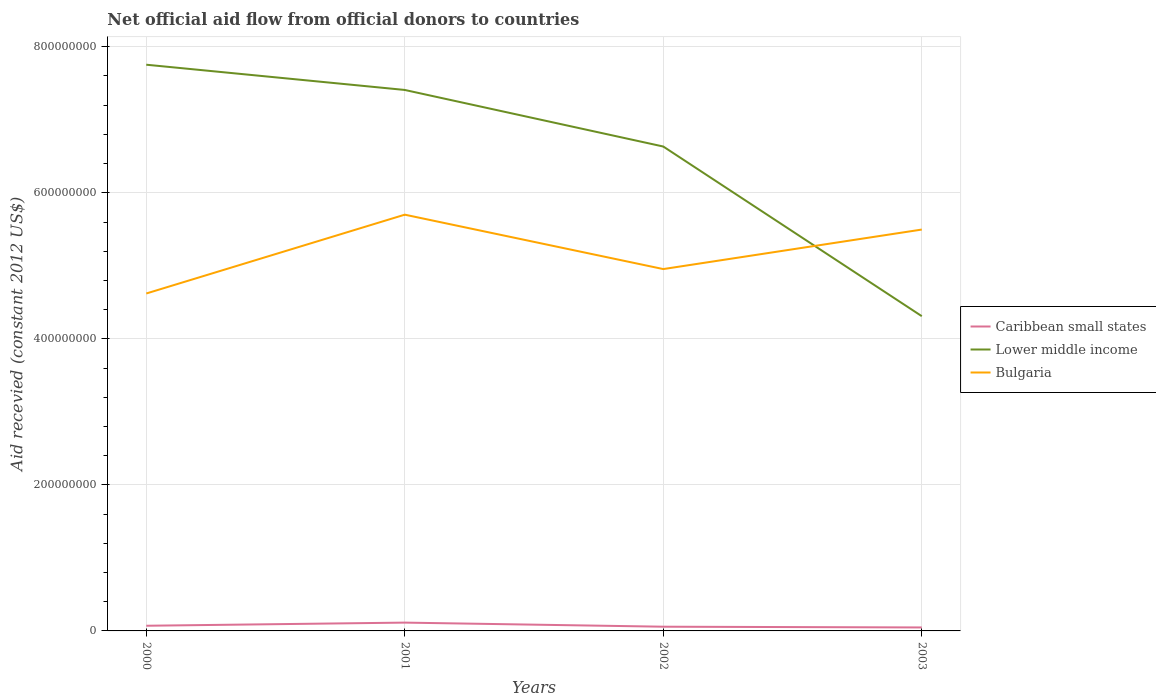How many different coloured lines are there?
Ensure brevity in your answer.  3. Does the line corresponding to Lower middle income intersect with the line corresponding to Bulgaria?
Your answer should be very brief. Yes. Across all years, what is the maximum total aid received in Caribbean small states?
Provide a succinct answer. 4.76e+06. What is the total total aid received in Lower middle income in the graph?
Your response must be concise. 3.44e+08. What is the difference between the highest and the second highest total aid received in Caribbean small states?
Keep it short and to the point. 6.62e+06. What is the difference between the highest and the lowest total aid received in Lower middle income?
Make the answer very short. 3. How many lines are there?
Keep it short and to the point. 3. Are the values on the major ticks of Y-axis written in scientific E-notation?
Give a very brief answer. No. Does the graph contain any zero values?
Provide a succinct answer. No. Does the graph contain grids?
Offer a terse response. Yes. Where does the legend appear in the graph?
Offer a terse response. Center right. What is the title of the graph?
Provide a short and direct response. Net official aid flow from official donors to countries. What is the label or title of the X-axis?
Offer a terse response. Years. What is the label or title of the Y-axis?
Ensure brevity in your answer.  Aid recevied (constant 2012 US$). What is the Aid recevied (constant 2012 US$) in Caribbean small states in 2000?
Make the answer very short. 7.08e+06. What is the Aid recevied (constant 2012 US$) in Lower middle income in 2000?
Make the answer very short. 7.75e+08. What is the Aid recevied (constant 2012 US$) in Bulgaria in 2000?
Keep it short and to the point. 4.62e+08. What is the Aid recevied (constant 2012 US$) in Caribbean small states in 2001?
Offer a very short reply. 1.14e+07. What is the Aid recevied (constant 2012 US$) in Lower middle income in 2001?
Your answer should be compact. 7.41e+08. What is the Aid recevied (constant 2012 US$) of Bulgaria in 2001?
Offer a terse response. 5.70e+08. What is the Aid recevied (constant 2012 US$) in Caribbean small states in 2002?
Make the answer very short. 5.78e+06. What is the Aid recevied (constant 2012 US$) in Lower middle income in 2002?
Your answer should be compact. 6.63e+08. What is the Aid recevied (constant 2012 US$) of Bulgaria in 2002?
Offer a very short reply. 4.96e+08. What is the Aid recevied (constant 2012 US$) in Caribbean small states in 2003?
Provide a short and direct response. 4.76e+06. What is the Aid recevied (constant 2012 US$) in Lower middle income in 2003?
Your answer should be very brief. 4.31e+08. What is the Aid recevied (constant 2012 US$) in Bulgaria in 2003?
Your answer should be compact. 5.50e+08. Across all years, what is the maximum Aid recevied (constant 2012 US$) in Caribbean small states?
Provide a short and direct response. 1.14e+07. Across all years, what is the maximum Aid recevied (constant 2012 US$) in Lower middle income?
Provide a succinct answer. 7.75e+08. Across all years, what is the maximum Aid recevied (constant 2012 US$) in Bulgaria?
Provide a succinct answer. 5.70e+08. Across all years, what is the minimum Aid recevied (constant 2012 US$) in Caribbean small states?
Keep it short and to the point. 4.76e+06. Across all years, what is the minimum Aid recevied (constant 2012 US$) of Lower middle income?
Offer a terse response. 4.31e+08. Across all years, what is the minimum Aid recevied (constant 2012 US$) of Bulgaria?
Offer a very short reply. 4.62e+08. What is the total Aid recevied (constant 2012 US$) in Caribbean small states in the graph?
Offer a terse response. 2.90e+07. What is the total Aid recevied (constant 2012 US$) in Lower middle income in the graph?
Give a very brief answer. 2.61e+09. What is the total Aid recevied (constant 2012 US$) of Bulgaria in the graph?
Your answer should be compact. 2.08e+09. What is the difference between the Aid recevied (constant 2012 US$) of Caribbean small states in 2000 and that in 2001?
Ensure brevity in your answer.  -4.30e+06. What is the difference between the Aid recevied (constant 2012 US$) in Lower middle income in 2000 and that in 2001?
Provide a short and direct response. 3.46e+07. What is the difference between the Aid recevied (constant 2012 US$) of Bulgaria in 2000 and that in 2001?
Keep it short and to the point. -1.08e+08. What is the difference between the Aid recevied (constant 2012 US$) in Caribbean small states in 2000 and that in 2002?
Offer a very short reply. 1.30e+06. What is the difference between the Aid recevied (constant 2012 US$) in Lower middle income in 2000 and that in 2002?
Give a very brief answer. 1.12e+08. What is the difference between the Aid recevied (constant 2012 US$) in Bulgaria in 2000 and that in 2002?
Your response must be concise. -3.34e+07. What is the difference between the Aid recevied (constant 2012 US$) in Caribbean small states in 2000 and that in 2003?
Provide a succinct answer. 2.32e+06. What is the difference between the Aid recevied (constant 2012 US$) in Lower middle income in 2000 and that in 2003?
Your response must be concise. 3.44e+08. What is the difference between the Aid recevied (constant 2012 US$) of Bulgaria in 2000 and that in 2003?
Your answer should be compact. -8.76e+07. What is the difference between the Aid recevied (constant 2012 US$) in Caribbean small states in 2001 and that in 2002?
Give a very brief answer. 5.60e+06. What is the difference between the Aid recevied (constant 2012 US$) of Lower middle income in 2001 and that in 2002?
Your answer should be compact. 7.75e+07. What is the difference between the Aid recevied (constant 2012 US$) in Bulgaria in 2001 and that in 2002?
Give a very brief answer. 7.45e+07. What is the difference between the Aid recevied (constant 2012 US$) in Caribbean small states in 2001 and that in 2003?
Ensure brevity in your answer.  6.62e+06. What is the difference between the Aid recevied (constant 2012 US$) of Lower middle income in 2001 and that in 2003?
Provide a short and direct response. 3.10e+08. What is the difference between the Aid recevied (constant 2012 US$) of Bulgaria in 2001 and that in 2003?
Give a very brief answer. 2.04e+07. What is the difference between the Aid recevied (constant 2012 US$) of Caribbean small states in 2002 and that in 2003?
Make the answer very short. 1.02e+06. What is the difference between the Aid recevied (constant 2012 US$) of Lower middle income in 2002 and that in 2003?
Your answer should be very brief. 2.32e+08. What is the difference between the Aid recevied (constant 2012 US$) of Bulgaria in 2002 and that in 2003?
Give a very brief answer. -5.41e+07. What is the difference between the Aid recevied (constant 2012 US$) in Caribbean small states in 2000 and the Aid recevied (constant 2012 US$) in Lower middle income in 2001?
Keep it short and to the point. -7.34e+08. What is the difference between the Aid recevied (constant 2012 US$) in Caribbean small states in 2000 and the Aid recevied (constant 2012 US$) in Bulgaria in 2001?
Offer a terse response. -5.63e+08. What is the difference between the Aid recevied (constant 2012 US$) of Lower middle income in 2000 and the Aid recevied (constant 2012 US$) of Bulgaria in 2001?
Give a very brief answer. 2.05e+08. What is the difference between the Aid recevied (constant 2012 US$) in Caribbean small states in 2000 and the Aid recevied (constant 2012 US$) in Lower middle income in 2002?
Make the answer very short. -6.56e+08. What is the difference between the Aid recevied (constant 2012 US$) of Caribbean small states in 2000 and the Aid recevied (constant 2012 US$) of Bulgaria in 2002?
Your answer should be compact. -4.88e+08. What is the difference between the Aid recevied (constant 2012 US$) in Lower middle income in 2000 and the Aid recevied (constant 2012 US$) in Bulgaria in 2002?
Offer a terse response. 2.80e+08. What is the difference between the Aid recevied (constant 2012 US$) in Caribbean small states in 2000 and the Aid recevied (constant 2012 US$) in Lower middle income in 2003?
Make the answer very short. -4.24e+08. What is the difference between the Aid recevied (constant 2012 US$) in Caribbean small states in 2000 and the Aid recevied (constant 2012 US$) in Bulgaria in 2003?
Your answer should be compact. -5.43e+08. What is the difference between the Aid recevied (constant 2012 US$) in Lower middle income in 2000 and the Aid recevied (constant 2012 US$) in Bulgaria in 2003?
Your response must be concise. 2.26e+08. What is the difference between the Aid recevied (constant 2012 US$) in Caribbean small states in 2001 and the Aid recevied (constant 2012 US$) in Lower middle income in 2002?
Give a very brief answer. -6.52e+08. What is the difference between the Aid recevied (constant 2012 US$) of Caribbean small states in 2001 and the Aid recevied (constant 2012 US$) of Bulgaria in 2002?
Make the answer very short. -4.84e+08. What is the difference between the Aid recevied (constant 2012 US$) of Lower middle income in 2001 and the Aid recevied (constant 2012 US$) of Bulgaria in 2002?
Your response must be concise. 2.45e+08. What is the difference between the Aid recevied (constant 2012 US$) of Caribbean small states in 2001 and the Aid recevied (constant 2012 US$) of Lower middle income in 2003?
Provide a short and direct response. -4.20e+08. What is the difference between the Aid recevied (constant 2012 US$) in Caribbean small states in 2001 and the Aid recevied (constant 2012 US$) in Bulgaria in 2003?
Your response must be concise. -5.38e+08. What is the difference between the Aid recevied (constant 2012 US$) in Lower middle income in 2001 and the Aid recevied (constant 2012 US$) in Bulgaria in 2003?
Keep it short and to the point. 1.91e+08. What is the difference between the Aid recevied (constant 2012 US$) in Caribbean small states in 2002 and the Aid recevied (constant 2012 US$) in Lower middle income in 2003?
Ensure brevity in your answer.  -4.25e+08. What is the difference between the Aid recevied (constant 2012 US$) of Caribbean small states in 2002 and the Aid recevied (constant 2012 US$) of Bulgaria in 2003?
Offer a terse response. -5.44e+08. What is the difference between the Aid recevied (constant 2012 US$) of Lower middle income in 2002 and the Aid recevied (constant 2012 US$) of Bulgaria in 2003?
Offer a terse response. 1.14e+08. What is the average Aid recevied (constant 2012 US$) in Caribbean small states per year?
Make the answer very short. 7.25e+06. What is the average Aid recevied (constant 2012 US$) of Lower middle income per year?
Offer a terse response. 6.53e+08. What is the average Aid recevied (constant 2012 US$) in Bulgaria per year?
Make the answer very short. 5.19e+08. In the year 2000, what is the difference between the Aid recevied (constant 2012 US$) of Caribbean small states and Aid recevied (constant 2012 US$) of Lower middle income?
Your response must be concise. -7.68e+08. In the year 2000, what is the difference between the Aid recevied (constant 2012 US$) of Caribbean small states and Aid recevied (constant 2012 US$) of Bulgaria?
Provide a succinct answer. -4.55e+08. In the year 2000, what is the difference between the Aid recevied (constant 2012 US$) in Lower middle income and Aid recevied (constant 2012 US$) in Bulgaria?
Offer a very short reply. 3.13e+08. In the year 2001, what is the difference between the Aid recevied (constant 2012 US$) of Caribbean small states and Aid recevied (constant 2012 US$) of Lower middle income?
Ensure brevity in your answer.  -7.29e+08. In the year 2001, what is the difference between the Aid recevied (constant 2012 US$) in Caribbean small states and Aid recevied (constant 2012 US$) in Bulgaria?
Provide a succinct answer. -5.59e+08. In the year 2001, what is the difference between the Aid recevied (constant 2012 US$) in Lower middle income and Aid recevied (constant 2012 US$) in Bulgaria?
Give a very brief answer. 1.71e+08. In the year 2002, what is the difference between the Aid recevied (constant 2012 US$) of Caribbean small states and Aid recevied (constant 2012 US$) of Lower middle income?
Your answer should be very brief. -6.58e+08. In the year 2002, what is the difference between the Aid recevied (constant 2012 US$) of Caribbean small states and Aid recevied (constant 2012 US$) of Bulgaria?
Offer a very short reply. -4.90e+08. In the year 2002, what is the difference between the Aid recevied (constant 2012 US$) in Lower middle income and Aid recevied (constant 2012 US$) in Bulgaria?
Your answer should be very brief. 1.68e+08. In the year 2003, what is the difference between the Aid recevied (constant 2012 US$) of Caribbean small states and Aid recevied (constant 2012 US$) of Lower middle income?
Ensure brevity in your answer.  -4.26e+08. In the year 2003, what is the difference between the Aid recevied (constant 2012 US$) of Caribbean small states and Aid recevied (constant 2012 US$) of Bulgaria?
Keep it short and to the point. -5.45e+08. In the year 2003, what is the difference between the Aid recevied (constant 2012 US$) of Lower middle income and Aid recevied (constant 2012 US$) of Bulgaria?
Your answer should be very brief. -1.19e+08. What is the ratio of the Aid recevied (constant 2012 US$) in Caribbean small states in 2000 to that in 2001?
Provide a succinct answer. 0.62. What is the ratio of the Aid recevied (constant 2012 US$) of Lower middle income in 2000 to that in 2001?
Make the answer very short. 1.05. What is the ratio of the Aid recevied (constant 2012 US$) in Bulgaria in 2000 to that in 2001?
Provide a short and direct response. 0.81. What is the ratio of the Aid recevied (constant 2012 US$) in Caribbean small states in 2000 to that in 2002?
Your answer should be compact. 1.22. What is the ratio of the Aid recevied (constant 2012 US$) in Lower middle income in 2000 to that in 2002?
Your response must be concise. 1.17. What is the ratio of the Aid recevied (constant 2012 US$) of Bulgaria in 2000 to that in 2002?
Your response must be concise. 0.93. What is the ratio of the Aid recevied (constant 2012 US$) of Caribbean small states in 2000 to that in 2003?
Provide a succinct answer. 1.49. What is the ratio of the Aid recevied (constant 2012 US$) in Lower middle income in 2000 to that in 2003?
Provide a short and direct response. 1.8. What is the ratio of the Aid recevied (constant 2012 US$) in Bulgaria in 2000 to that in 2003?
Offer a very short reply. 0.84. What is the ratio of the Aid recevied (constant 2012 US$) in Caribbean small states in 2001 to that in 2002?
Your response must be concise. 1.97. What is the ratio of the Aid recevied (constant 2012 US$) of Lower middle income in 2001 to that in 2002?
Make the answer very short. 1.12. What is the ratio of the Aid recevied (constant 2012 US$) of Bulgaria in 2001 to that in 2002?
Your response must be concise. 1.15. What is the ratio of the Aid recevied (constant 2012 US$) of Caribbean small states in 2001 to that in 2003?
Your answer should be very brief. 2.39. What is the ratio of the Aid recevied (constant 2012 US$) of Lower middle income in 2001 to that in 2003?
Keep it short and to the point. 1.72. What is the ratio of the Aid recevied (constant 2012 US$) of Bulgaria in 2001 to that in 2003?
Make the answer very short. 1.04. What is the ratio of the Aid recevied (constant 2012 US$) of Caribbean small states in 2002 to that in 2003?
Your answer should be very brief. 1.21. What is the ratio of the Aid recevied (constant 2012 US$) in Lower middle income in 2002 to that in 2003?
Keep it short and to the point. 1.54. What is the ratio of the Aid recevied (constant 2012 US$) in Bulgaria in 2002 to that in 2003?
Your answer should be compact. 0.9. What is the difference between the highest and the second highest Aid recevied (constant 2012 US$) of Caribbean small states?
Offer a terse response. 4.30e+06. What is the difference between the highest and the second highest Aid recevied (constant 2012 US$) of Lower middle income?
Your answer should be compact. 3.46e+07. What is the difference between the highest and the second highest Aid recevied (constant 2012 US$) in Bulgaria?
Give a very brief answer. 2.04e+07. What is the difference between the highest and the lowest Aid recevied (constant 2012 US$) of Caribbean small states?
Your answer should be compact. 6.62e+06. What is the difference between the highest and the lowest Aid recevied (constant 2012 US$) in Lower middle income?
Provide a short and direct response. 3.44e+08. What is the difference between the highest and the lowest Aid recevied (constant 2012 US$) of Bulgaria?
Provide a succinct answer. 1.08e+08. 